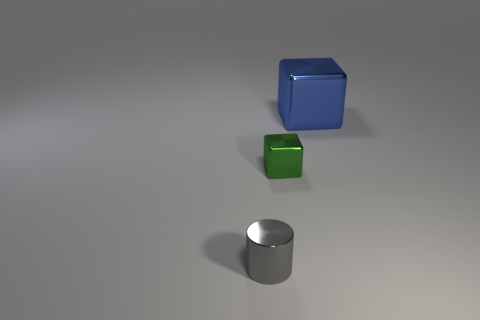Add 3 tiny things. How many objects exist? 6 Subtract all blocks. How many objects are left? 1 Subtract 0 red blocks. How many objects are left? 3 Subtract all small purple rubber things. Subtract all small green objects. How many objects are left? 2 Add 2 small gray shiny objects. How many small gray shiny objects are left? 3 Add 1 tiny shiny things. How many tiny shiny things exist? 3 